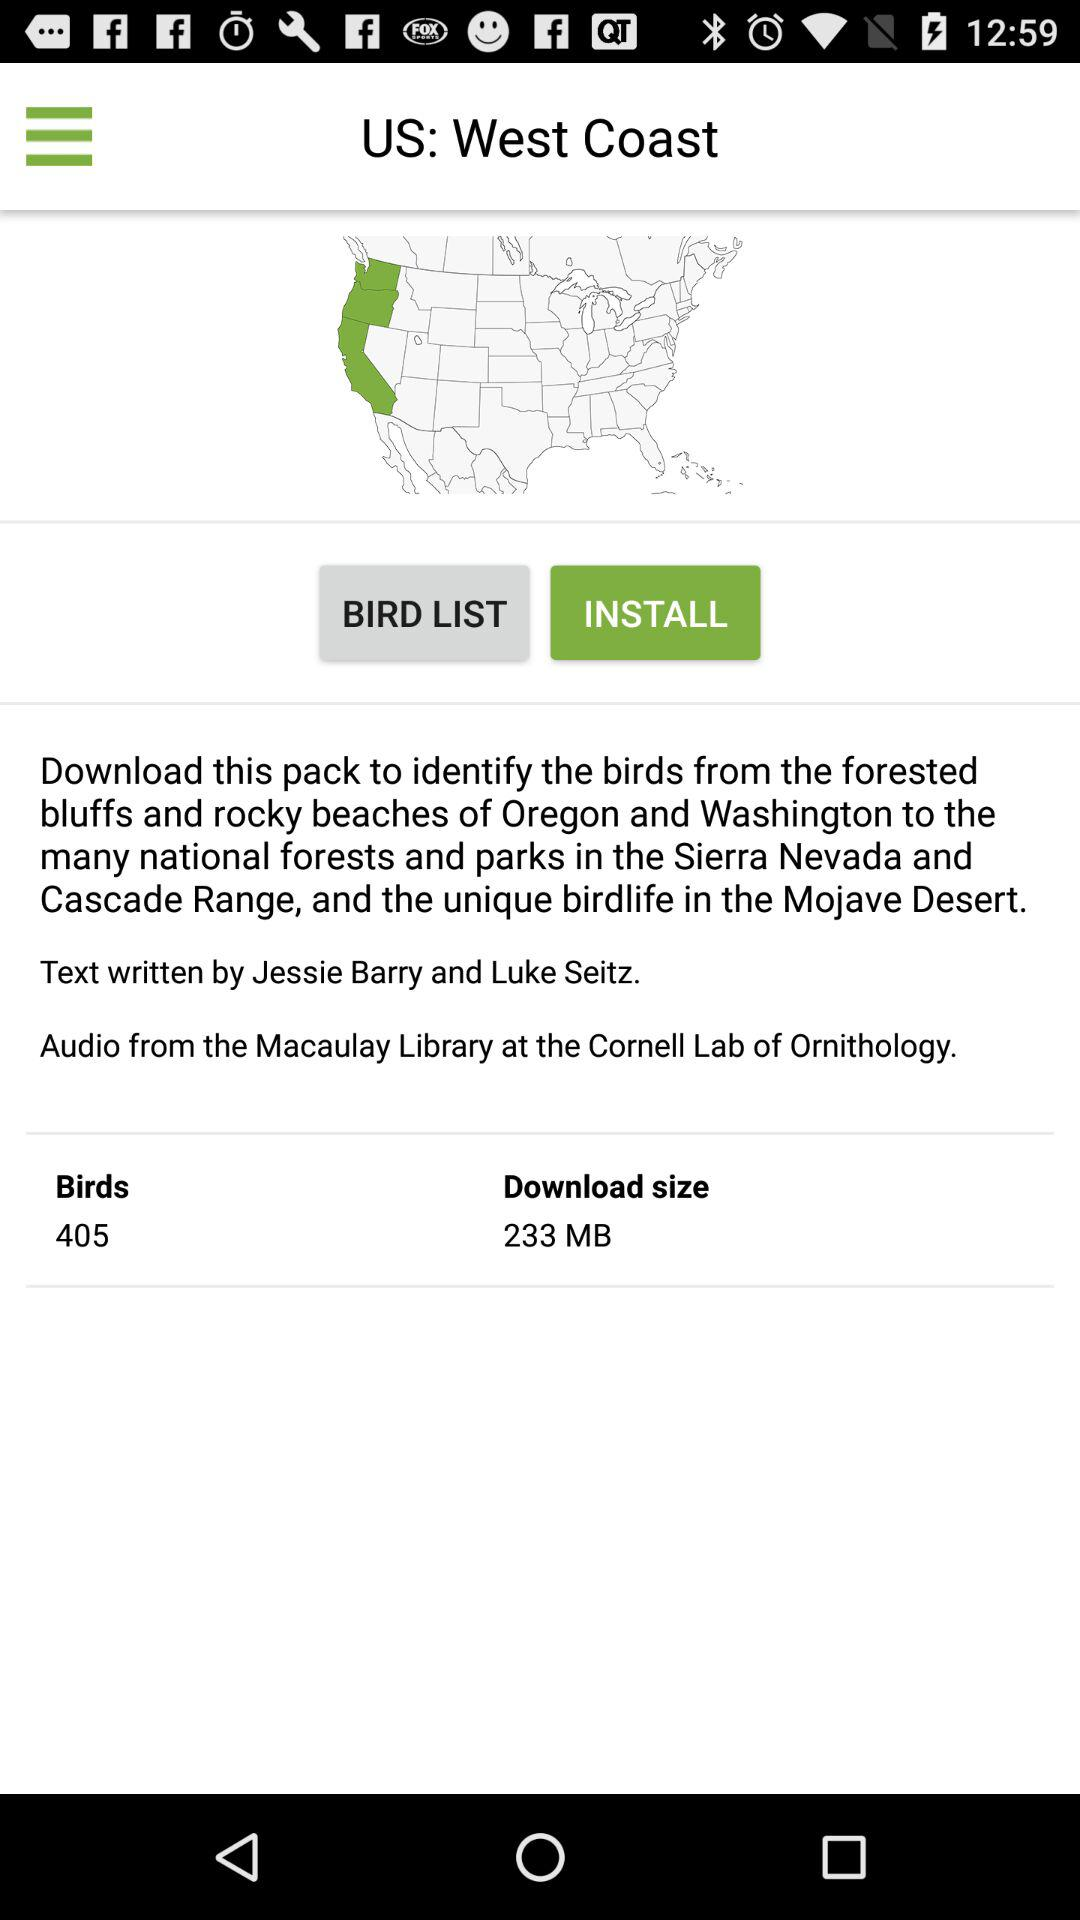How many total birds are there? There are 405 total birds. 